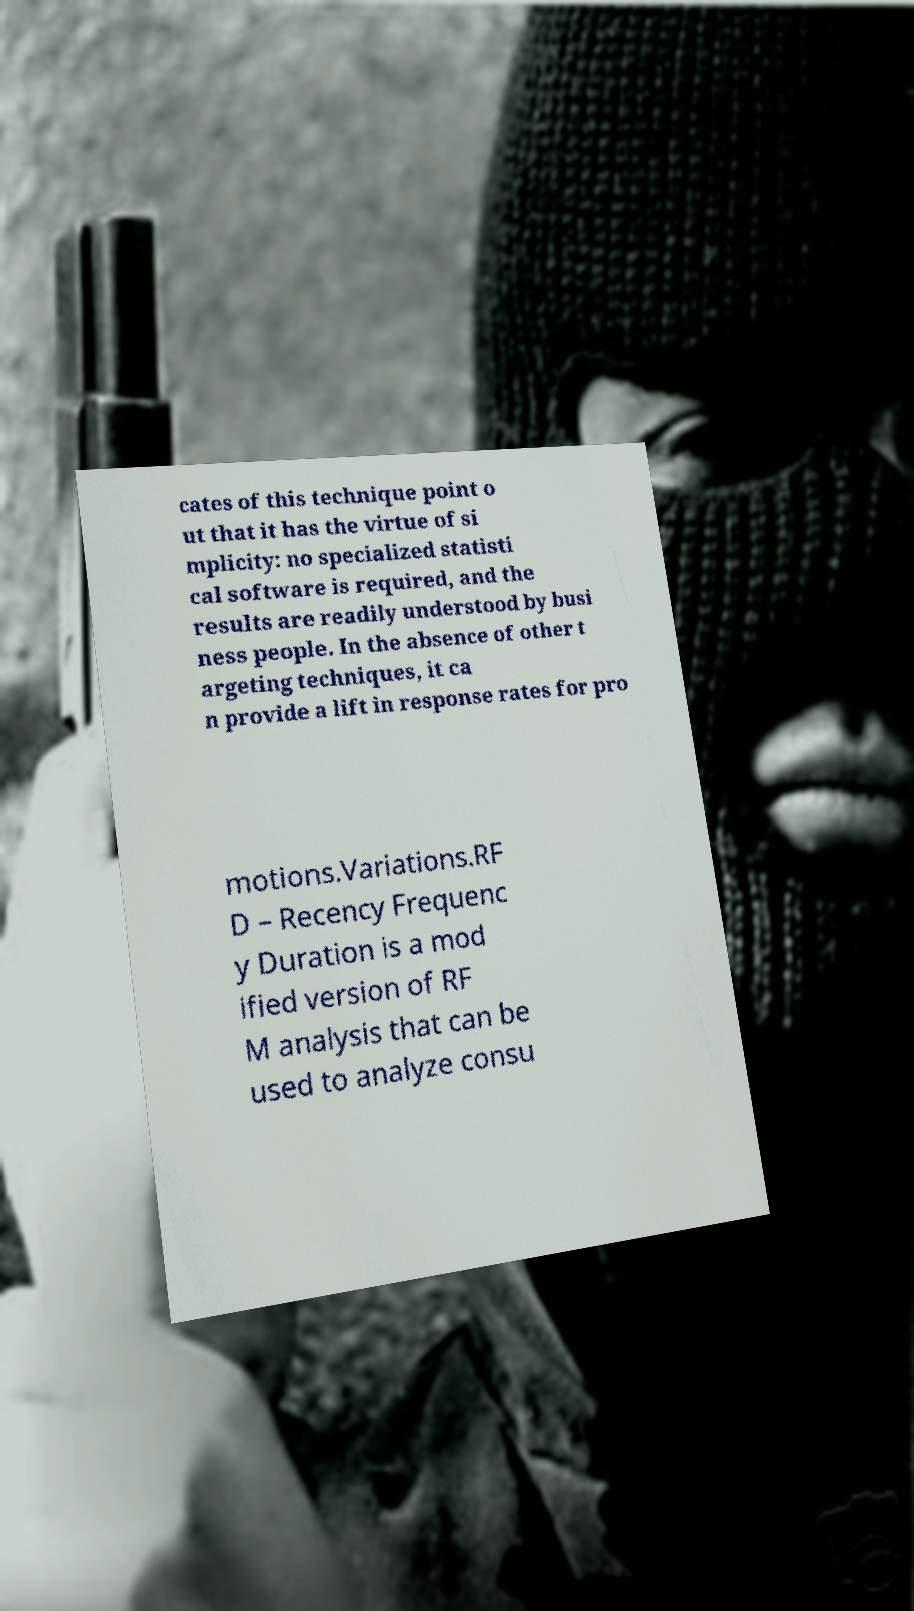I need the written content from this picture converted into text. Can you do that? cates of this technique point o ut that it has the virtue of si mplicity: no specialized statisti cal software is required, and the results are readily understood by busi ness people. In the absence of other t argeting techniques, it ca n provide a lift in response rates for pro motions.Variations.RF D – Recency Frequenc y Duration is a mod ified version of RF M analysis that can be used to analyze consu 